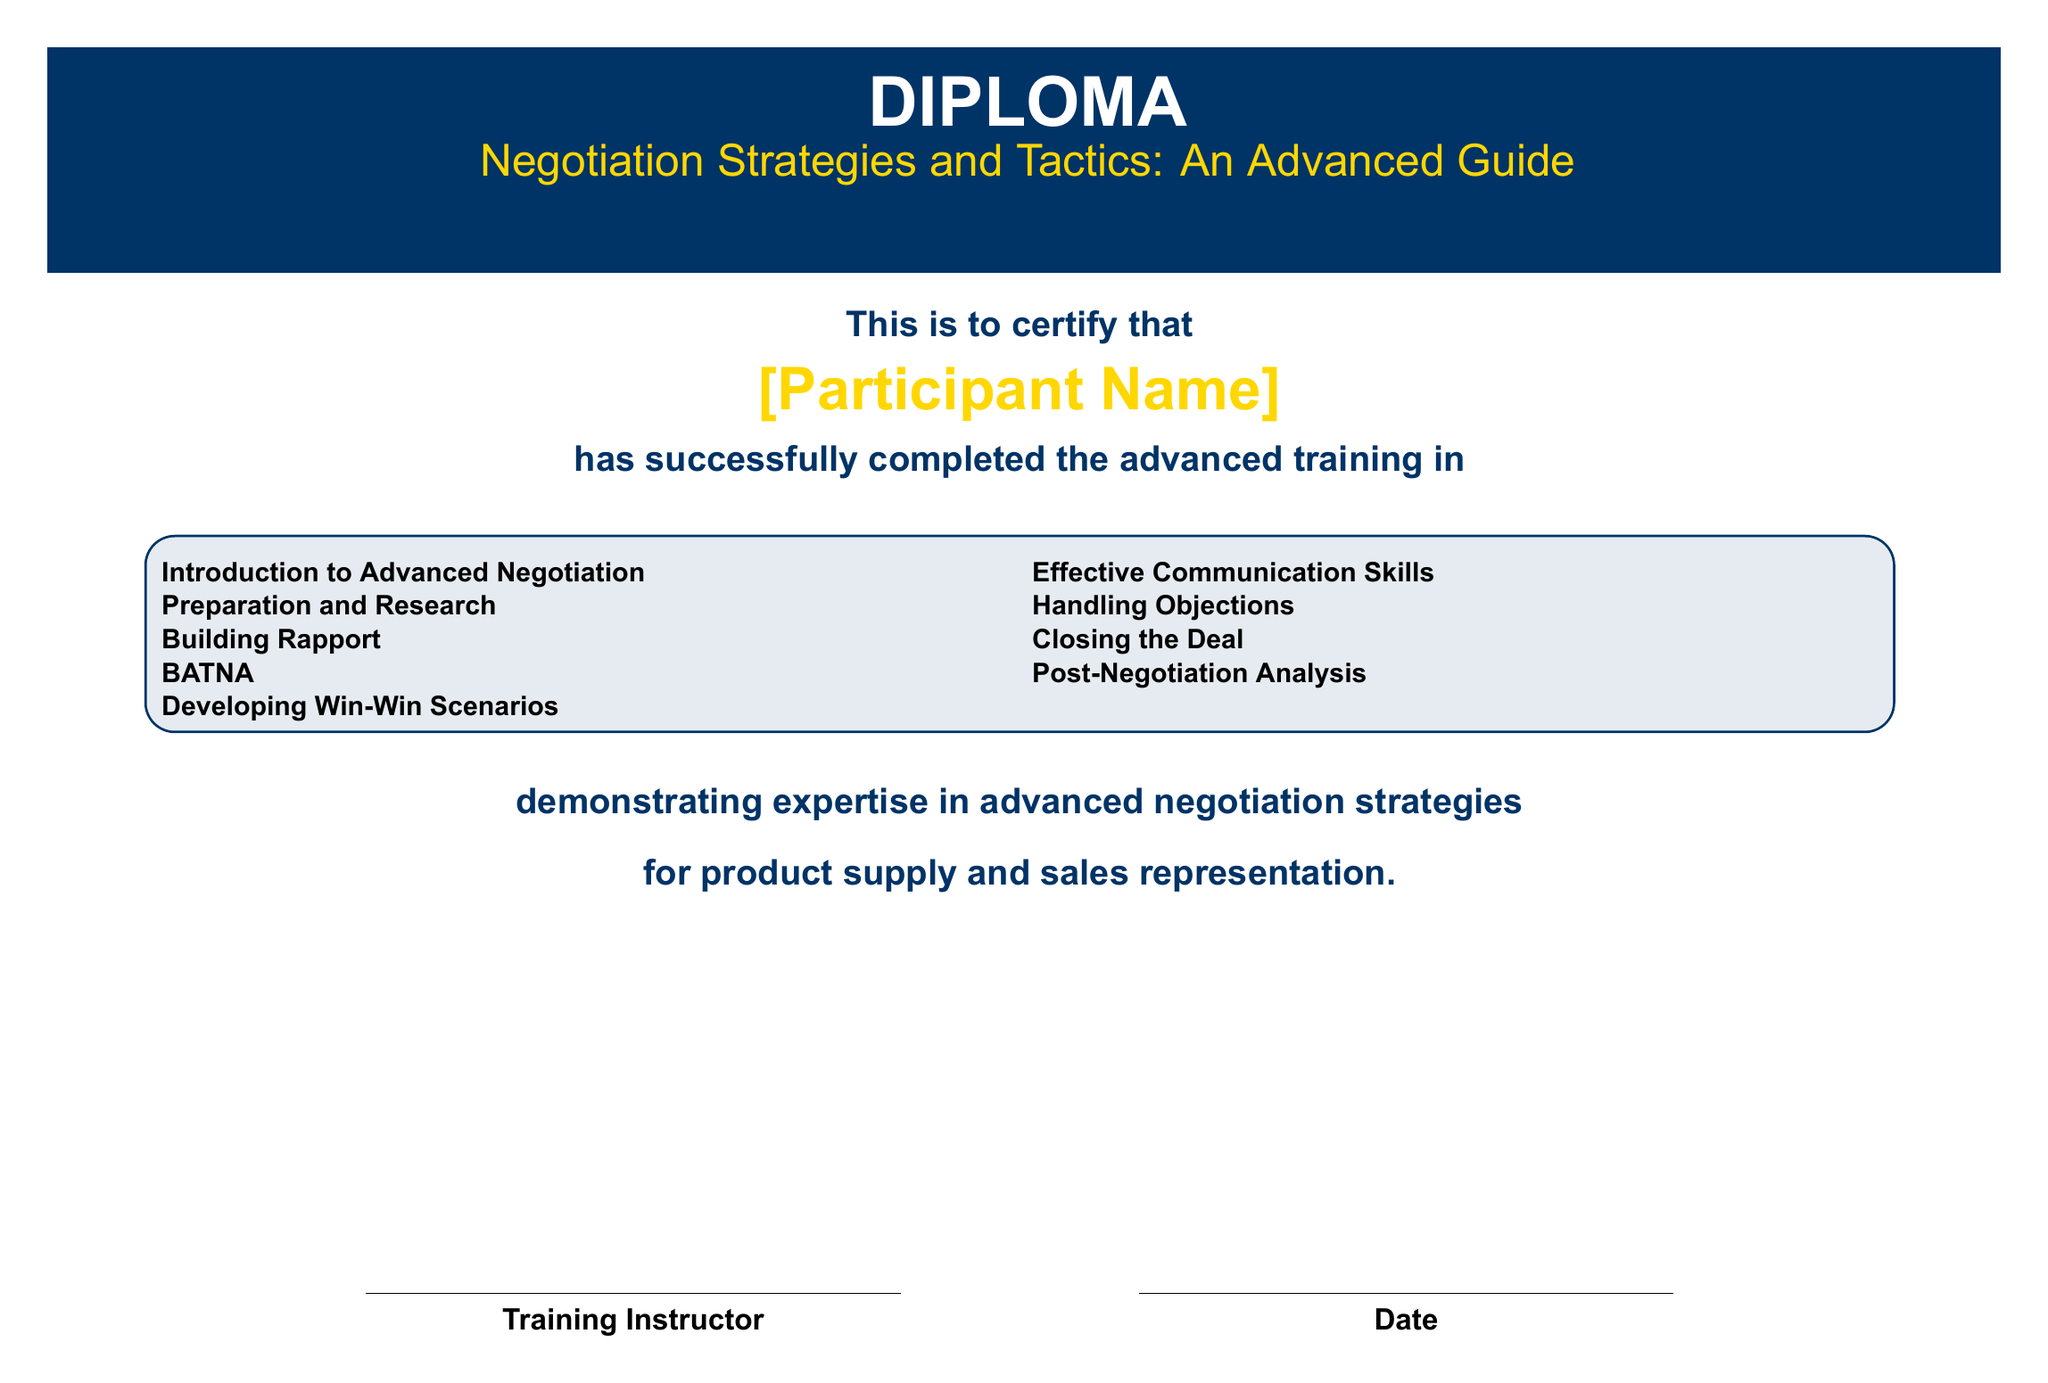What is the title of the diploma? The title of the diploma is explicitly mentioned in the document as "Negotiation Strategies and Tactics: An Advanced Guide."
Answer: Negotiation Strategies and Tactics: An Advanced Guide Who is the participant of the training? The participant's name is indicated as "[Participant Name]" in the document.
Answer: [Participant Name] What is the focus of the diploma? The diploma emphasizes expertise in advanced negotiation strategies for a specific area mentioned in the document.
Answer: product supply and sales representation How many core subjects are listed in the diploma? The document lists a total of eight core subjects under the "Training" section.
Answer: 8 What color is used for the background of the diploma? The background color of the diploma is specified to be white in the document.
Answer: white Who certifies the training completion? The training completion is certified by the "Training Instructor" whose name is mentioned in the document.
Answer: Training Instructor What is the purpose of this diploma? The purpose of the diploma is to certify successful completion of advanced training in a specific field.
Answer: certify successful completion What is the first subject mentioned in the core subjects? The first subject listed under the training section is "Introduction to Advanced Negotiation."
Answer: Introduction to Advanced Negotiation 